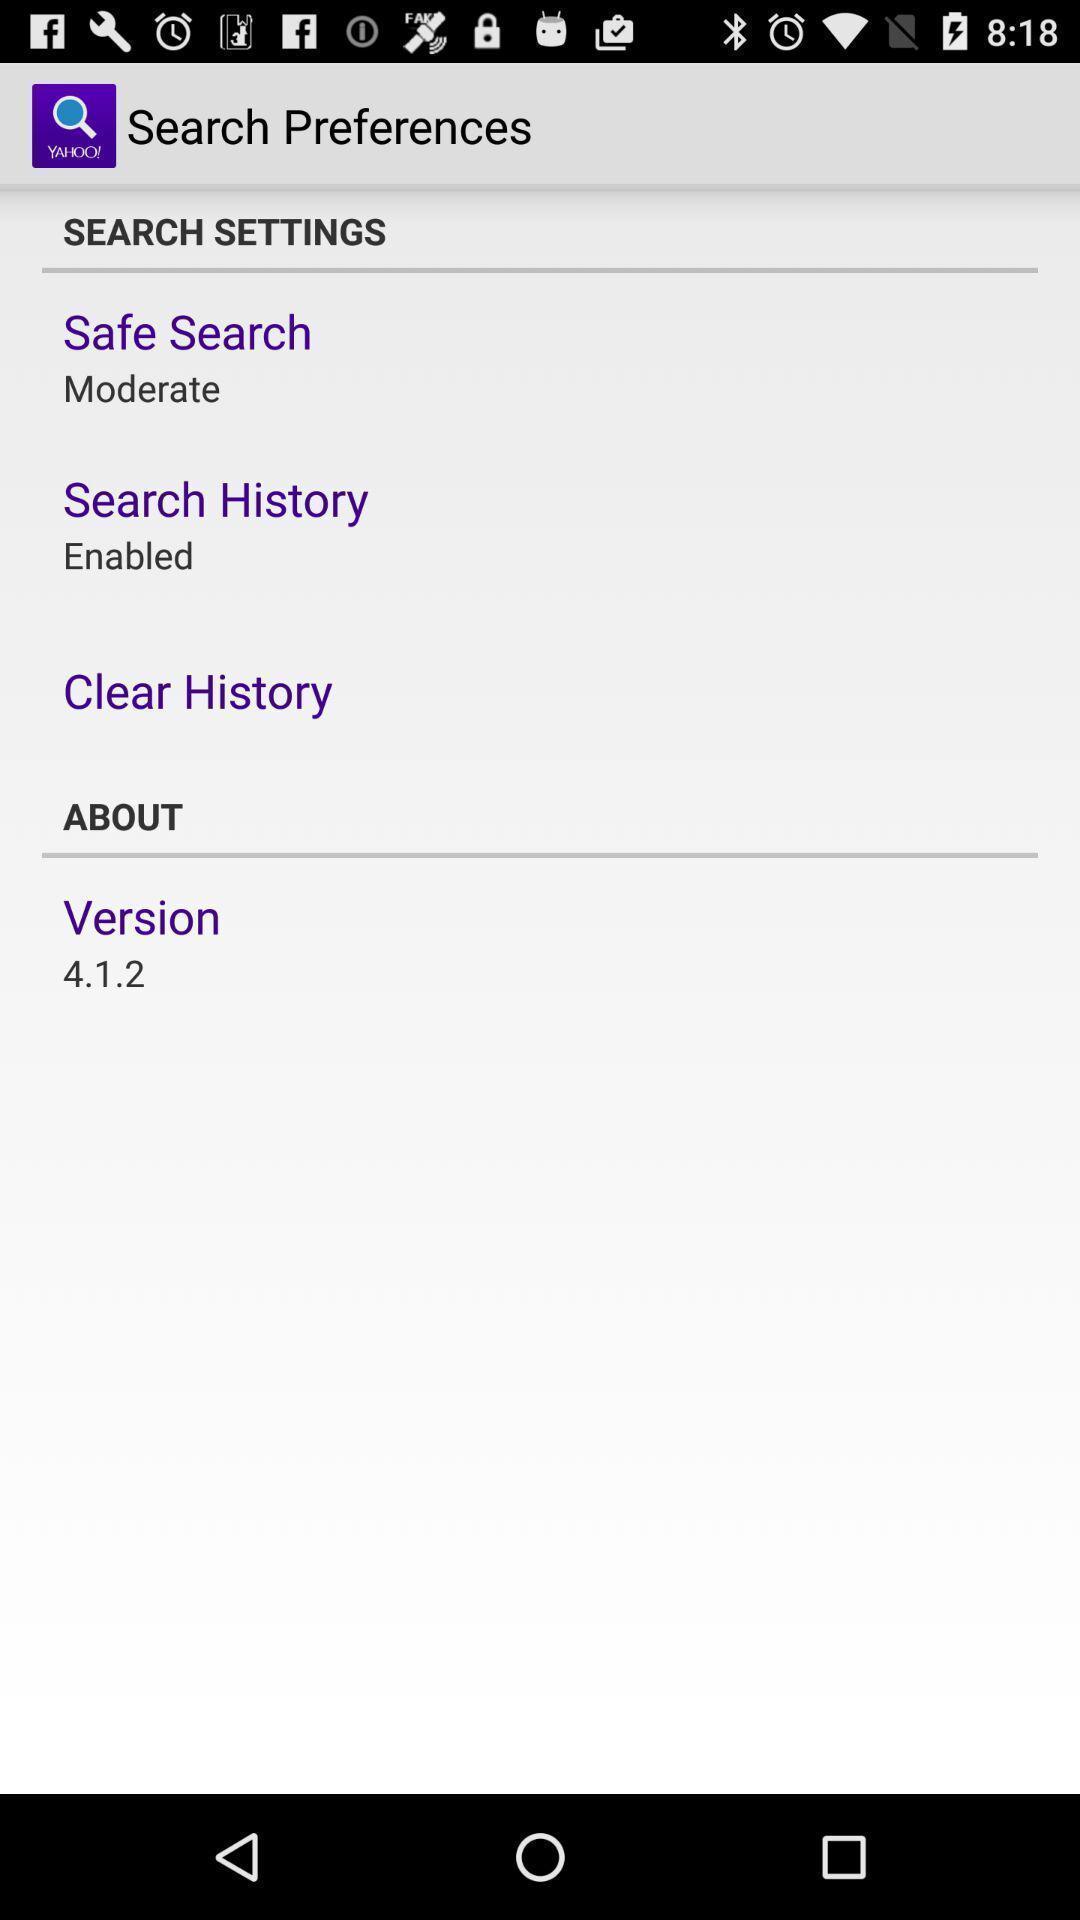Summarize the main components in this picture. Setting page displaying the various options. 